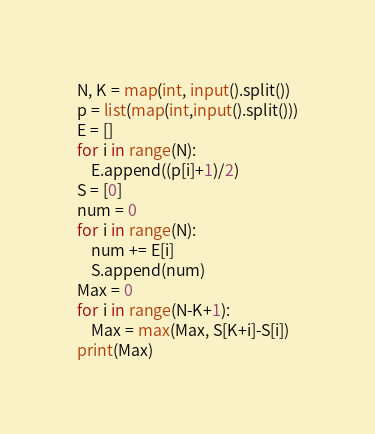Convert code to text. <code><loc_0><loc_0><loc_500><loc_500><_Python_>N, K = map(int, input().split())
p = list(map(int,input().split()))
E = []
for i in range(N):
    E.append((p[i]+1)/2)
S = [0]
num = 0
for i in range(N):
    num += E[i]
    S.append(num)
Max = 0
for i in range(N-K+1):
    Max = max(Max, S[K+i]-S[i])
print(Max)</code> 